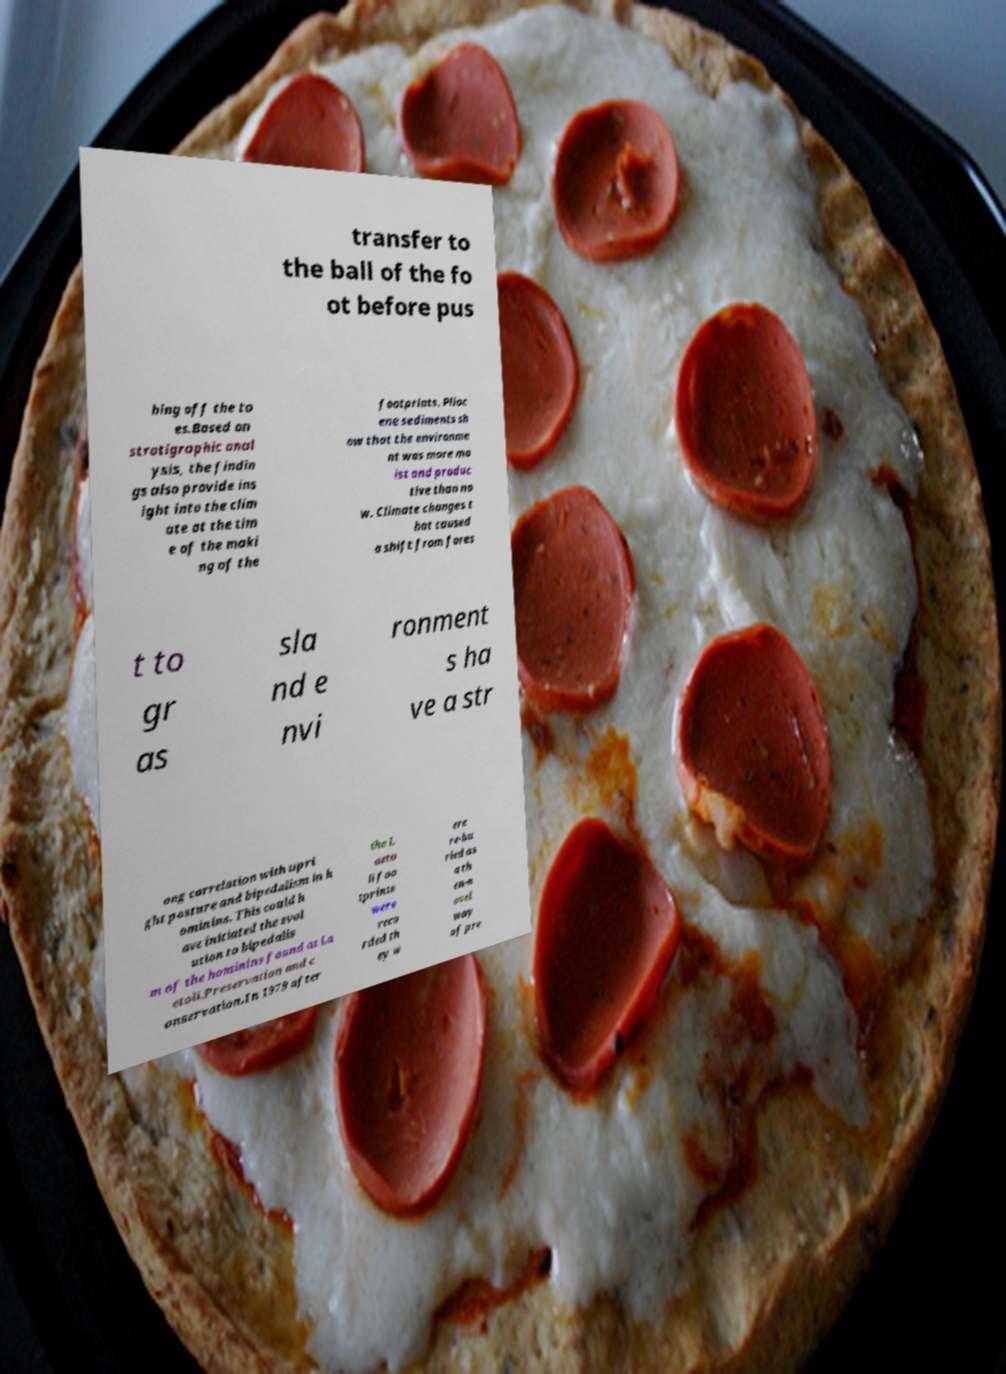Could you extract and type out the text from this image? transfer to the ball of the fo ot before pus hing off the to es.Based on stratigraphic anal ysis, the findin gs also provide ins ight into the clim ate at the tim e of the maki ng of the footprints. Plioc ene sediments sh ow that the environme nt was more mo ist and produc tive than no w. Climate changes t hat caused a shift from fores t to gr as sla nd e nvi ronment s ha ve a str ong correlation with upri ght posture and bipedalism in h ominins. This could h ave initiated the evol ution to bipedalis m of the hominins found at La etoli.Preservation and c onservation.In 1979 after the L aeto li foo tprints were reco rded th ey w ere re-bu ried as a th en-n ovel way of pre 